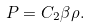<formula> <loc_0><loc_0><loc_500><loc_500>P = C _ { 2 } \beta \rho .</formula> 